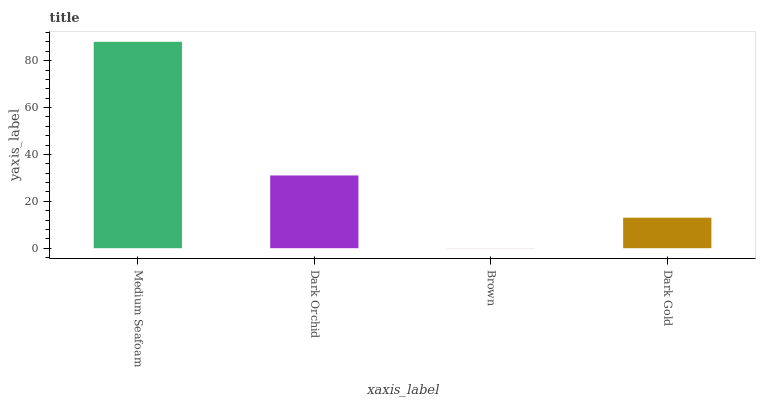Is Brown the minimum?
Answer yes or no. Yes. Is Medium Seafoam the maximum?
Answer yes or no. Yes. Is Dark Orchid the minimum?
Answer yes or no. No. Is Dark Orchid the maximum?
Answer yes or no. No. Is Medium Seafoam greater than Dark Orchid?
Answer yes or no. Yes. Is Dark Orchid less than Medium Seafoam?
Answer yes or no. Yes. Is Dark Orchid greater than Medium Seafoam?
Answer yes or no. No. Is Medium Seafoam less than Dark Orchid?
Answer yes or no. No. Is Dark Orchid the high median?
Answer yes or no. Yes. Is Dark Gold the low median?
Answer yes or no. Yes. Is Brown the high median?
Answer yes or no. No. Is Dark Orchid the low median?
Answer yes or no. No. 